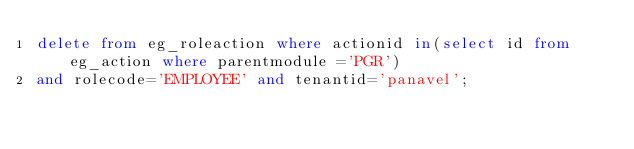<code> <loc_0><loc_0><loc_500><loc_500><_SQL_>delete from eg_roleaction where actionid in(select id from eg_action where parentmodule ='PGR')
and rolecode='EMPLOYEE' and tenantid='panavel';</code> 